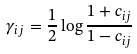Convert formula to latex. <formula><loc_0><loc_0><loc_500><loc_500>\gamma _ { i j } = \frac { 1 } { 2 } \log \frac { 1 + c _ { i j } } { 1 - c _ { i j } }</formula> 